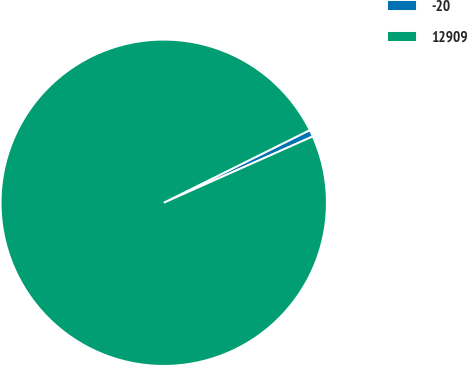Convert chart to OTSL. <chart><loc_0><loc_0><loc_500><loc_500><pie_chart><fcel>-20<fcel>12909<nl><fcel>0.68%<fcel>99.32%<nl></chart> 